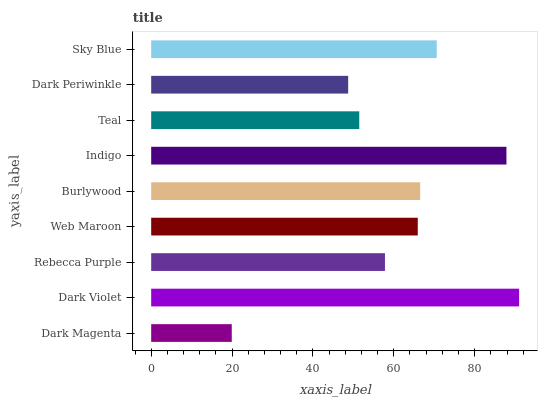Is Dark Magenta the minimum?
Answer yes or no. Yes. Is Dark Violet the maximum?
Answer yes or no. Yes. Is Rebecca Purple the minimum?
Answer yes or no. No. Is Rebecca Purple the maximum?
Answer yes or no. No. Is Dark Violet greater than Rebecca Purple?
Answer yes or no. Yes. Is Rebecca Purple less than Dark Violet?
Answer yes or no. Yes. Is Rebecca Purple greater than Dark Violet?
Answer yes or no. No. Is Dark Violet less than Rebecca Purple?
Answer yes or no. No. Is Web Maroon the high median?
Answer yes or no. Yes. Is Web Maroon the low median?
Answer yes or no. Yes. Is Burlywood the high median?
Answer yes or no. No. Is Burlywood the low median?
Answer yes or no. No. 